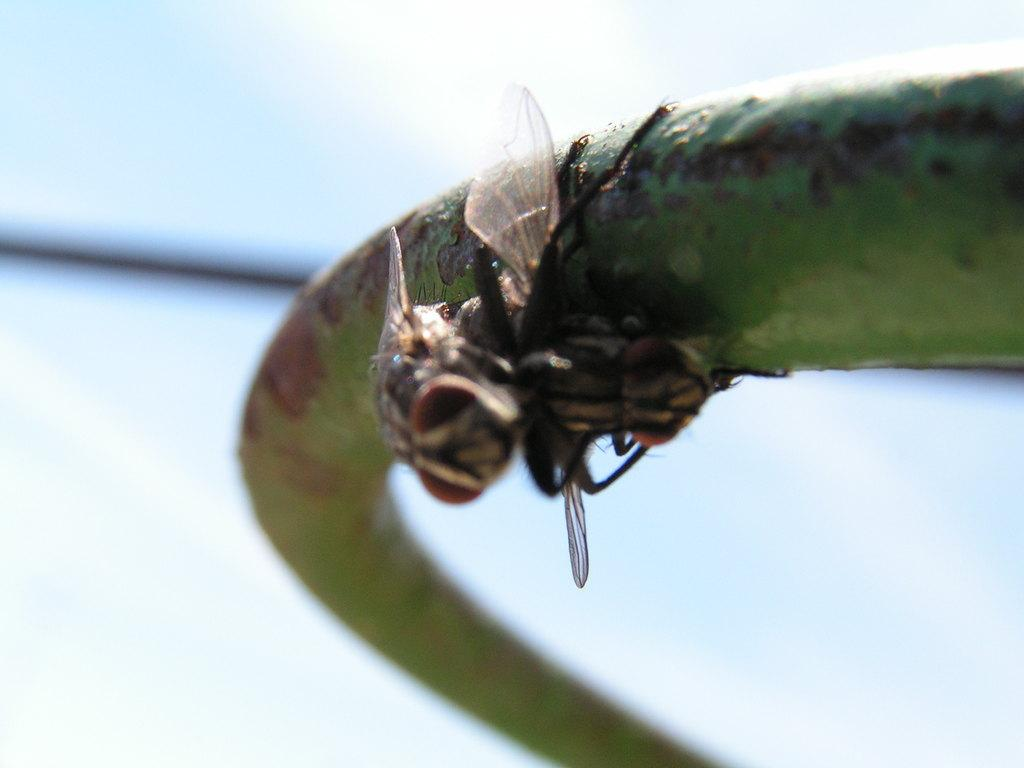What color is the main object in the image? The main object in the image is green. What can be seen on the green object? There are insects on the green object. How would you describe the overall clarity of the image? The image is slightly blurry in the background. How many cats can be seen playing with the lizards in the image? There are no cats or lizards present in the image; it features a green object with insects on it. 